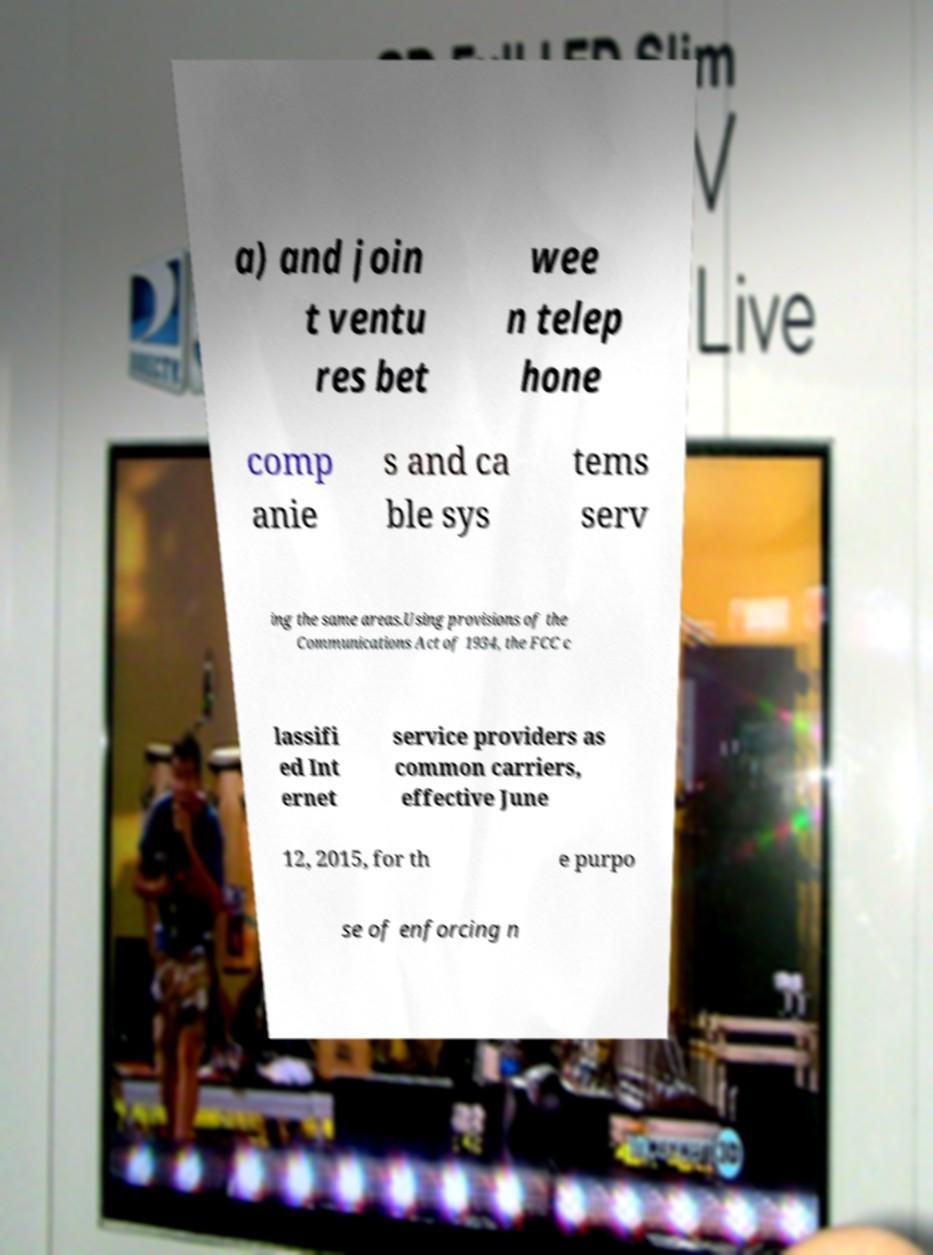I need the written content from this picture converted into text. Can you do that? a) and join t ventu res bet wee n telep hone comp anie s and ca ble sys tems serv ing the same areas.Using provisions of the Communications Act of 1934, the FCC c lassifi ed Int ernet service providers as common carriers, effective June 12, 2015, for th e purpo se of enforcing n 